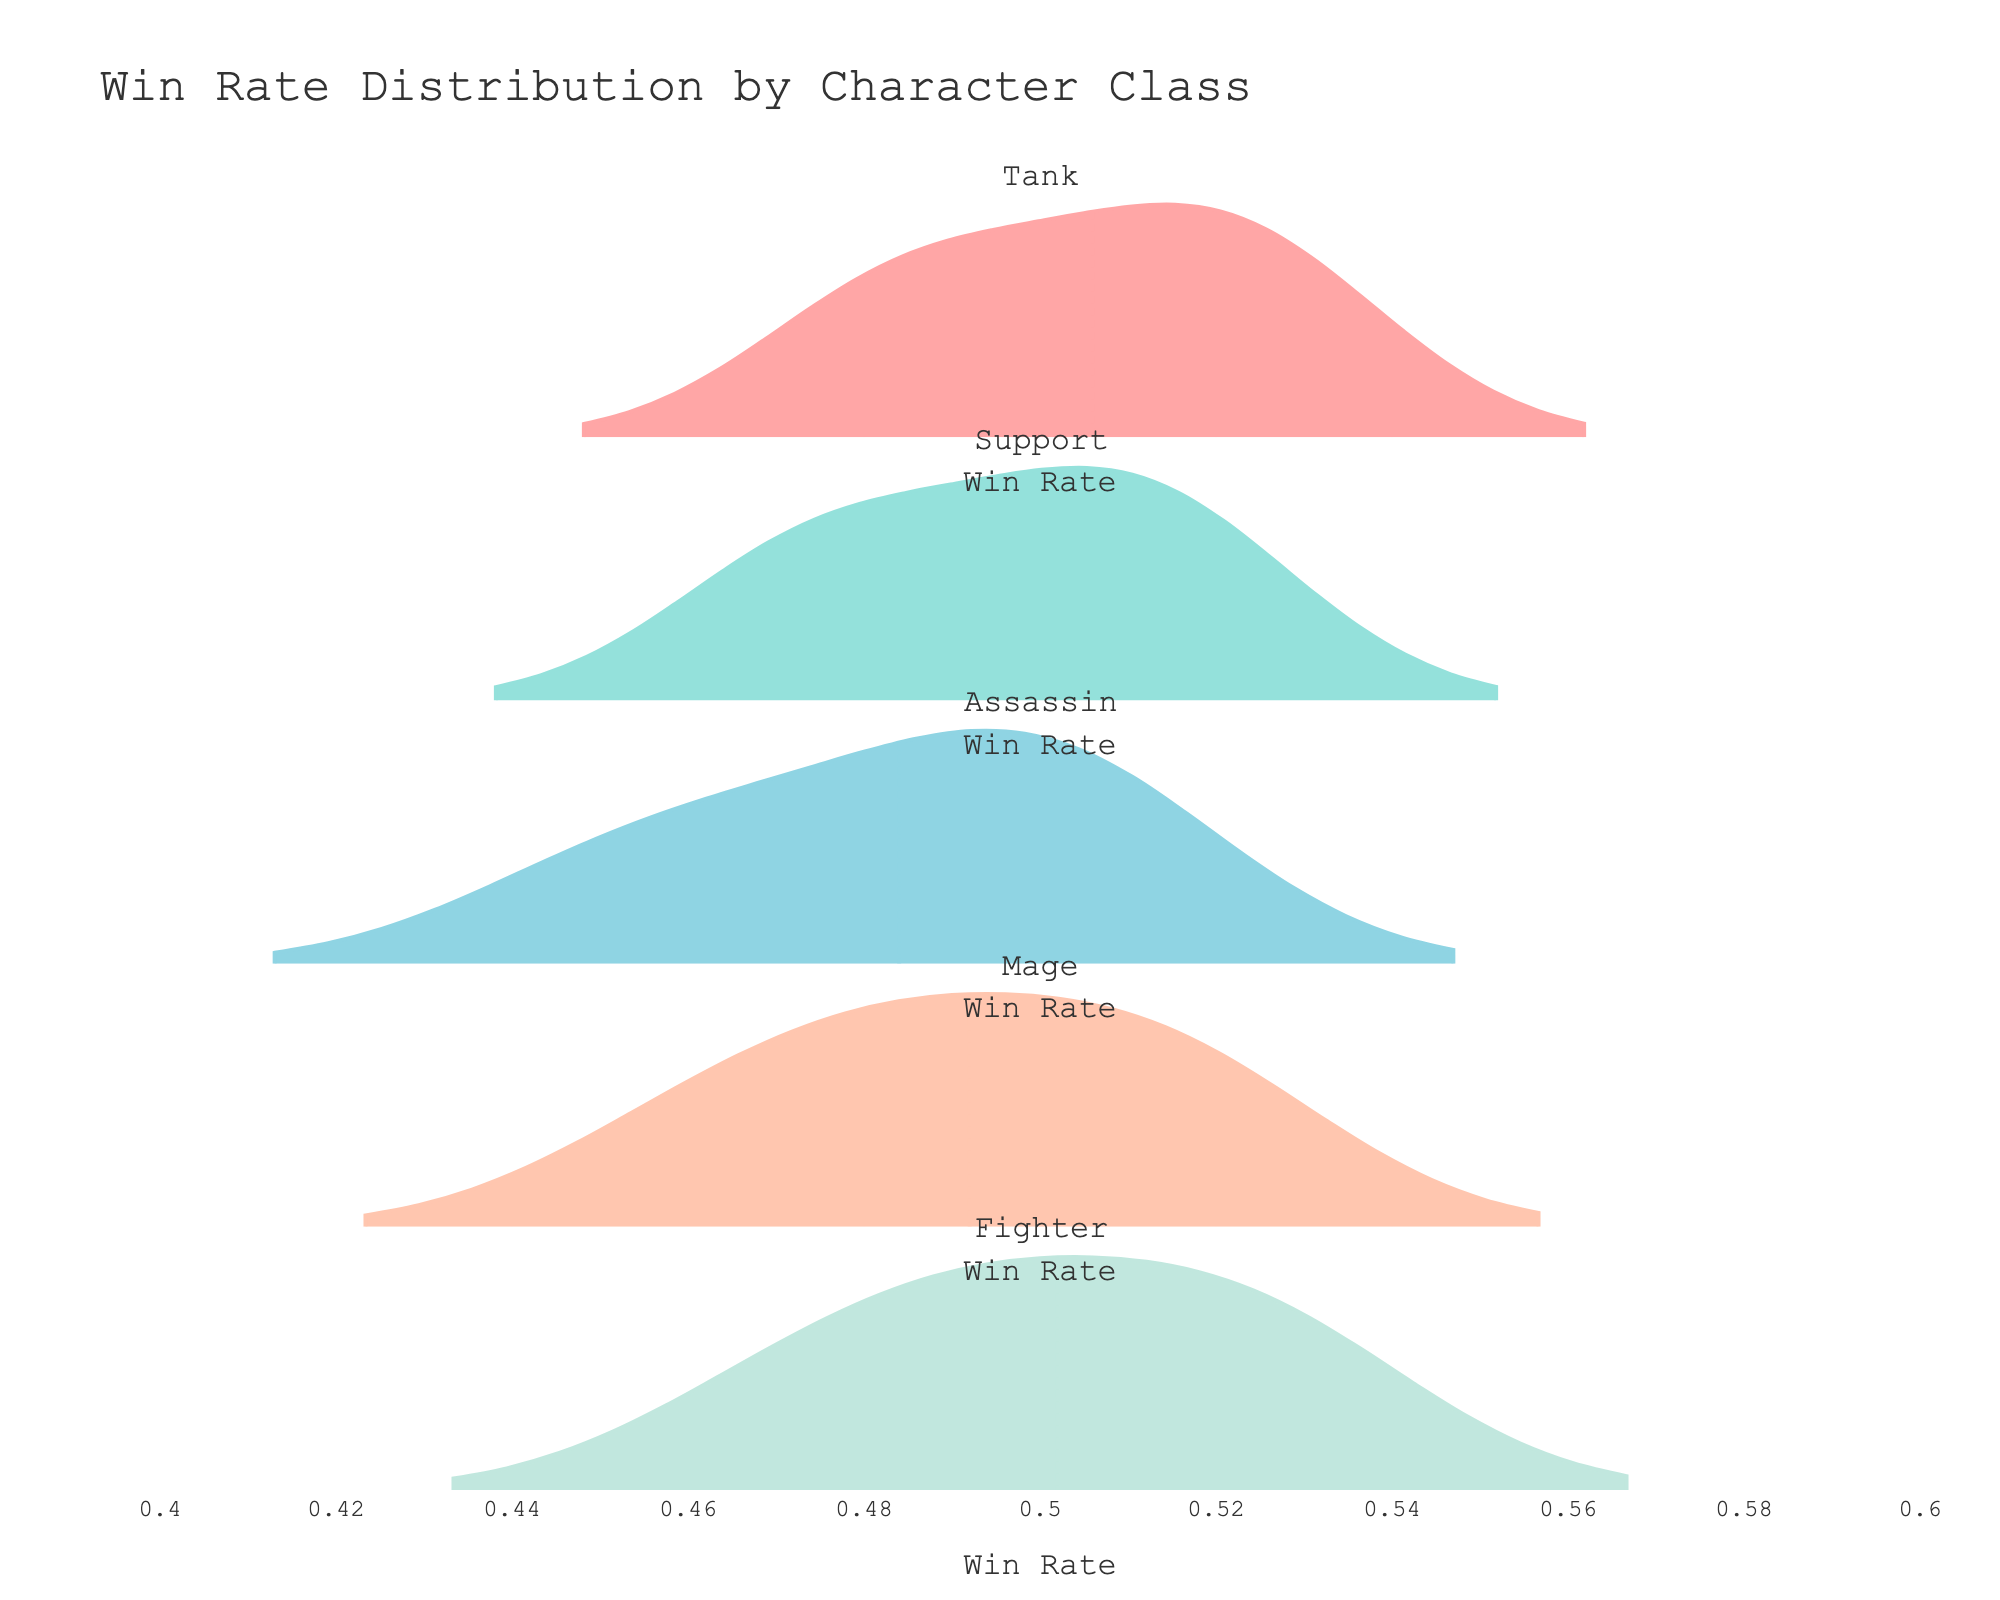What's the title of the figure? The title of the figure is prominently displayed at the top.
Answer: Win Rate Distribution by Character Class What is the x-axis representing? The label of the x-axis indicates what is being measured along that axis.
Answer: Win Rate Which character class has the highest median win rate? For violin plots, the median is usually marked by a line in the middle of the plot. You can compare these medians by looking at the middle lines of each class.
Answer: Fighter How many character classes are being compared in the figure? Each subplot title represents a different character class, count these titles.
Answer: Five Which character class shows the most variability in win rates? Variability can be assessed by the width and spread of the violin plot. A wider and more dispersed plot indicates higher variability.
Answer: Assassin What's the approximate range of win rates for the Mage class? The range can be estimated by looking at the spread of the Mage's violin plot from the lowest to the highest point.
Answer: 0.46 to 0.52 Do any character classes have overlapping win rate ranges? Compare the win rate ranges of different character classes from 0.46 to 0.53. If more than one class falls within this range, they overlap.
Answer: Yes Which character class has the lowest minimum win rate? The lowest minimum win rate can be identified by the bottom end of each violin plot.
Answer: Assassin On average, do Tanks have higher or lower win rates than Supports? By comparing the centers of the Tank and Support plots visually, one can infer which has a higher central tendency.
Answer: Higher Are there any character classes with the exact same median win rate? Compare the median lines (usually marked within the violin plots) to see if any two are aligned.
Answer: Yes, Support and Mage 